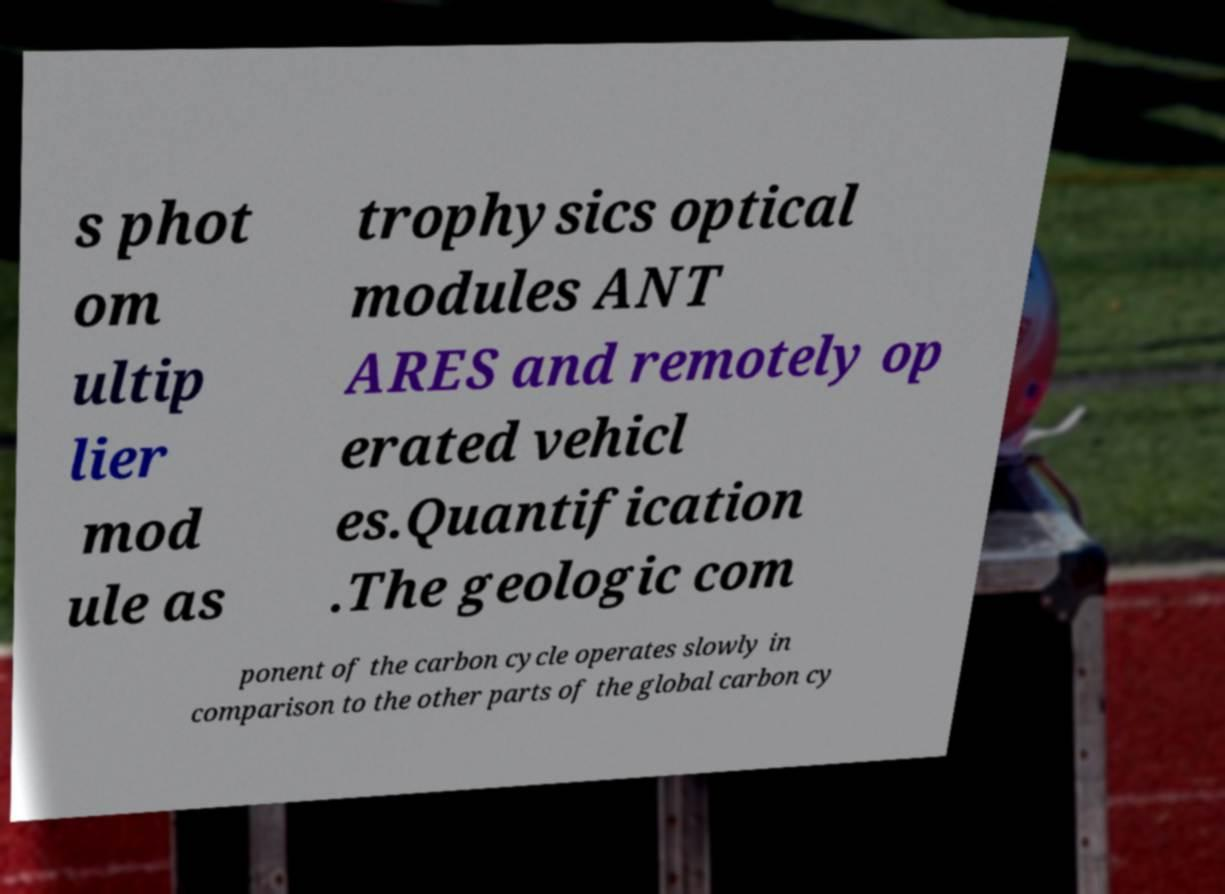There's text embedded in this image that I need extracted. Can you transcribe it verbatim? s phot om ultip lier mod ule as trophysics optical modules ANT ARES and remotely op erated vehicl es.Quantification .The geologic com ponent of the carbon cycle operates slowly in comparison to the other parts of the global carbon cy 